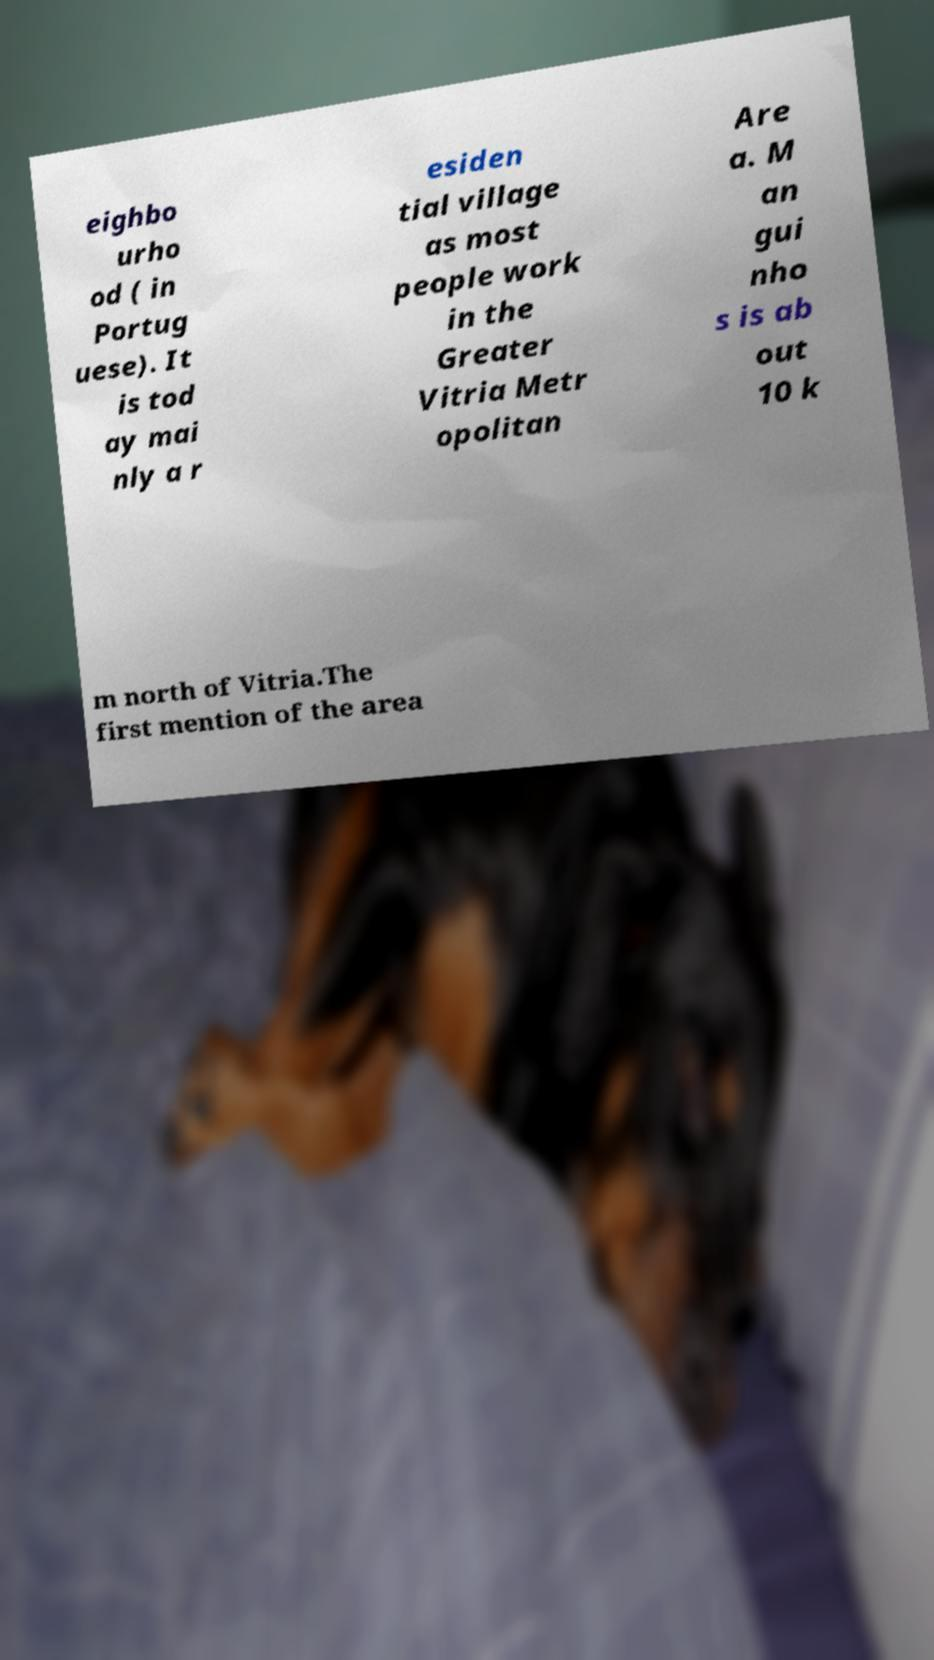Please identify and transcribe the text found in this image. eighbo urho od ( in Portug uese). It is tod ay mai nly a r esiden tial village as most people work in the Greater Vitria Metr opolitan Are a. M an gui nho s is ab out 10 k m north of Vitria.The first mention of the area 